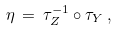Convert formula to latex. <formula><loc_0><loc_0><loc_500><loc_500>\eta \, = \, \tau ^ { - 1 } _ { Z } \circ \tau _ { Y } \, ,</formula> 